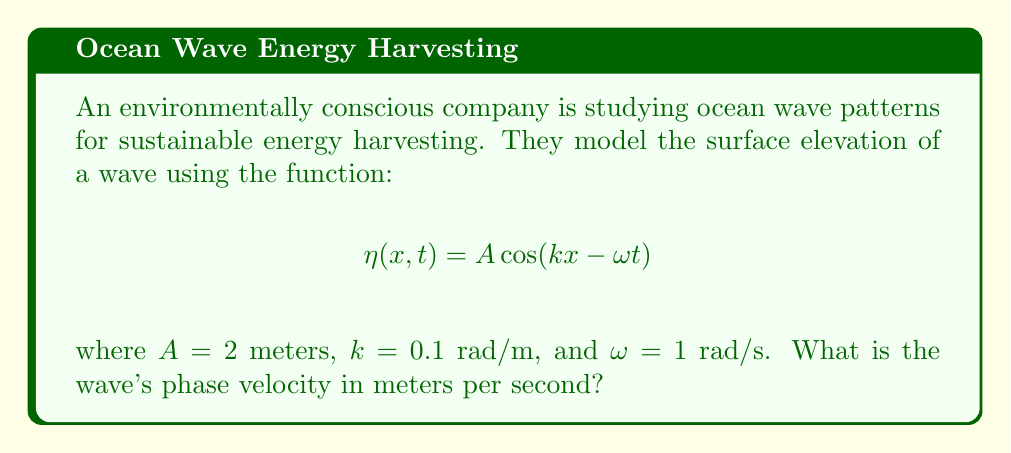Teach me how to tackle this problem. To find the phase velocity of the wave, we can follow these steps:

1) The general form of a wave equation is:

   $$\eta(x,t) = A \cos(kx - \omega t)$$

   where:
   - $A$ is the amplitude
   - $k$ is the wavenumber
   - $\omega$ is the angular frequency

2) The phase velocity, $c$, is given by the relationship:

   $$c = \frac{\omega}{k}$$

3) We are given:
   - $\omega = 1$ rad/s
   - $k = 0.1$ rad/m

4) Substituting these values into the phase velocity equation:

   $$c = \frac{1 \text{ rad/s}}{0.1 \text{ rad/m}}$$

5) Simplifying:

   $$c = 10 \text{ m/s}$$

Thus, the wave's phase velocity is 10 meters per second.
Answer: 10 m/s 